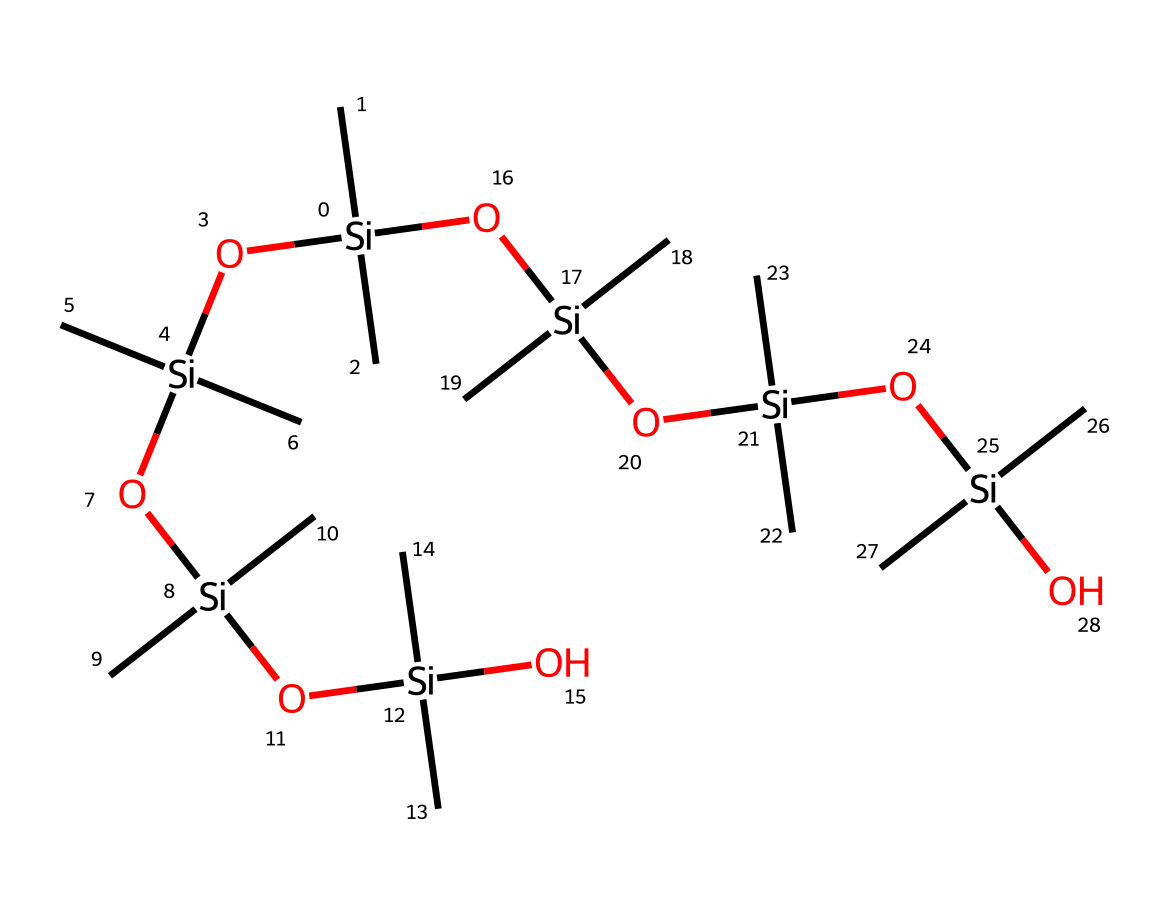What is the main element present in this chemical's backbone? The structure displays multiple silicon (Si) atoms, indicating that silicon forms the core backbone of the polymer.
Answer: silicon How many silicon atoms are present in the SMILES representation? By counting the occurrences of [Si], we find that there are 6 silicon atoms in total.
Answer: 6 What kind of bonds connect the silicon atoms in this structure? The silicon atoms are connected by silicon-oxygen bonds, which are prevalent in siloxane structures, giving it stability and flexibility.
Answer: siloxane bonds What is the primary functional group present in this chemical? The presence of the hydroxyl group (-OH) attached to silicone indicates that the primary functional group is a silanol.
Answer: silanol What is the significance of the branching methyl groups in the structure? The methyl (C) groups provide flexibility and lower the density of the silicone rubber, enhancing its performance in protective gear applications.
Answer: flexibility Does this chemical contain any double bonds? The SMILES representation shows only single bonds between the silicon and oxygen atoms, indicating that there are no double bonds in this structure.
Answer: no What unique property does this silicone rubber provide for protective gear? The chemical structure allows silicone rubber to be resistant to heat and provide cushioning, making it ideal for protective applications.
Answer: heat resistance 